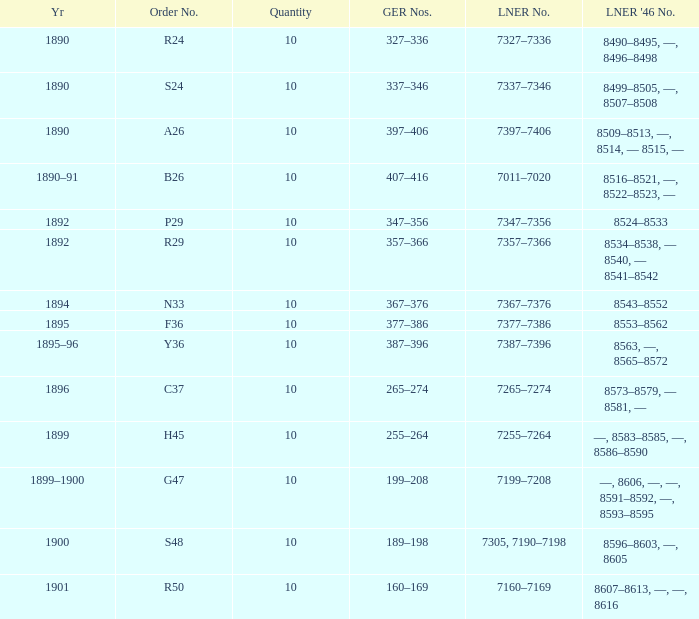Could you parse the entire table as a dict? {'header': ['Yr', 'Order No.', 'Quantity', 'GER Nos.', 'LNER No.', "LNER '46 No."], 'rows': [['1890', 'R24', '10', '327–336', '7327–7336', '8490–8495, —, 8496–8498'], ['1890', 'S24', '10', '337–346', '7337–7346', '8499–8505, —, 8507–8508'], ['1890', 'A26', '10', '397–406', '7397–7406', '8509–8513, —, 8514, — 8515, —'], ['1890–91', 'B26', '10', '407–416', '7011–7020', '8516–8521, —, 8522–8523, —'], ['1892', 'P29', '10', '347–356', '7347–7356', '8524–8533'], ['1892', 'R29', '10', '357–366', '7357–7366', '8534–8538, — 8540, — 8541–8542'], ['1894', 'N33', '10', '367–376', '7367–7376', '8543–8552'], ['1895', 'F36', '10', '377–386', '7377–7386', '8553–8562'], ['1895–96', 'Y36', '10', '387–396', '7387–7396', '8563, —, 8565–8572'], ['1896', 'C37', '10', '265–274', '7265–7274', '8573–8579, — 8581, —'], ['1899', 'H45', '10', '255–264', '7255–7264', '—, 8583–8585, —, 8586–8590'], ['1899–1900', 'G47', '10', '199–208', '7199–7208', '—, 8606, —, —, 8591–8592, —, 8593–8595'], ['1900', 'S48', '10', '189–198', '7305, 7190–7198', '8596–8603, —, 8605'], ['1901', 'R50', '10', '160–169', '7160–7169', '8607–8613, —, —, 8616']]} Which LNER 1946 number is from 1892 and has an LNER number of 7347–7356? 8524–8533. 